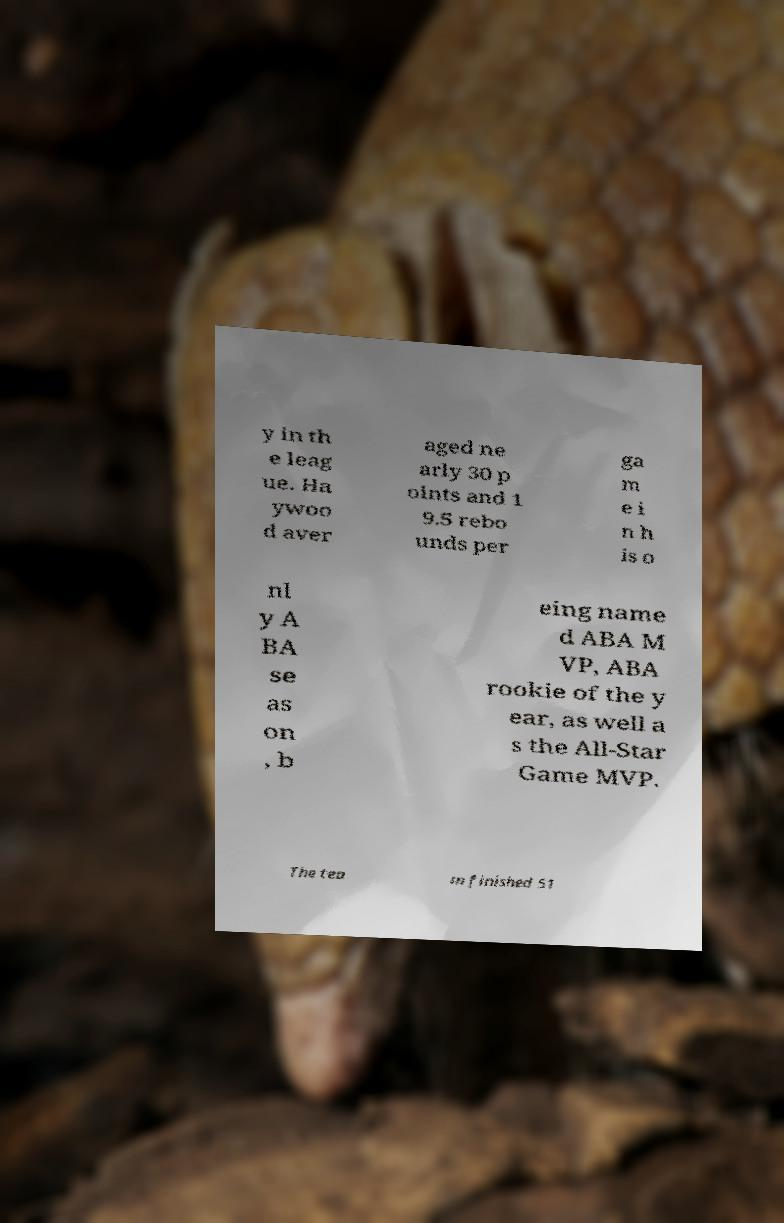Can you read and provide the text displayed in the image?This photo seems to have some interesting text. Can you extract and type it out for me? y in th e leag ue. Ha ywoo d aver aged ne arly 30 p oints and 1 9.5 rebo unds per ga m e i n h is o nl y A BA se as on , b eing name d ABA M VP, ABA rookie of the y ear, as well a s the All-Star Game MVP. The tea m finished 51 